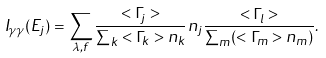Convert formula to latex. <formula><loc_0><loc_0><loc_500><loc_500>I _ { \gamma \gamma } ( E _ { j } ) = \sum _ { \lambda , f } \frac { < \Gamma _ { j } > } { \sum _ { k } < \Gamma _ { k } > n _ { k } } n _ { j } \frac { < \Gamma _ { l } > } { \sum _ { m } ( < \Gamma _ { m } > n _ { m } ) } .</formula> 